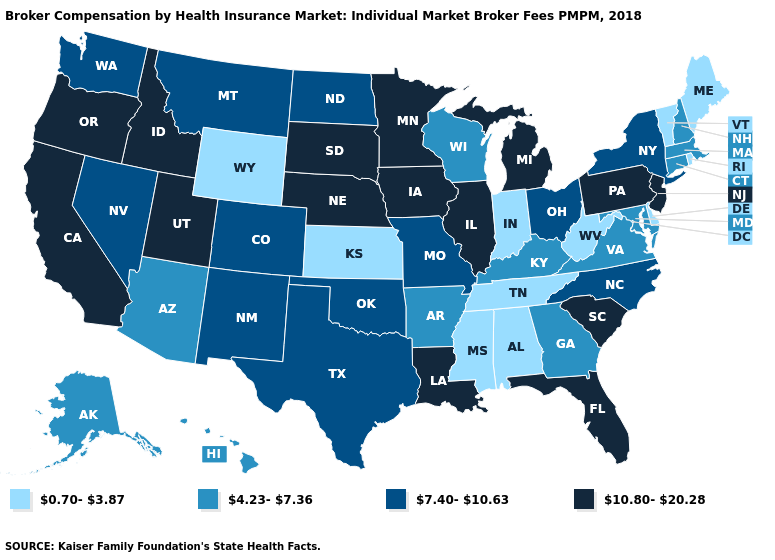What is the value of Arkansas?
Short answer required. 4.23-7.36. What is the value of Iowa?
Write a very short answer. 10.80-20.28. What is the value of North Dakota?
Write a very short answer. 7.40-10.63. Does South Dakota have the highest value in the MidWest?
Answer briefly. Yes. What is the value of Nebraska?
Quick response, please. 10.80-20.28. What is the value of Arizona?
Answer briefly. 4.23-7.36. Does Pennsylvania have the highest value in the Northeast?
Keep it brief. Yes. What is the value of Arkansas?
Quick response, please. 4.23-7.36. Among the states that border Montana , does South Dakota have the highest value?
Be succinct. Yes. Among the states that border North Carolina , does Tennessee have the highest value?
Keep it brief. No. What is the value of Kentucky?
Be succinct. 4.23-7.36. What is the value of Vermont?
Keep it brief. 0.70-3.87. Does the map have missing data?
Be succinct. No. What is the value of Florida?
Be succinct. 10.80-20.28. What is the value of Florida?
Be succinct. 10.80-20.28. 